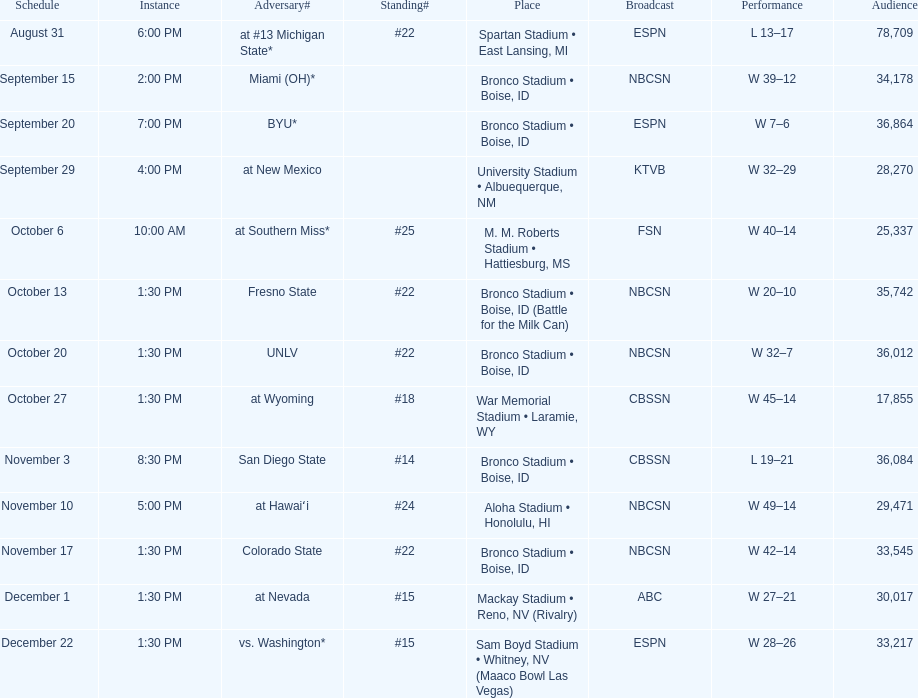What was the greatest number of back-to-back wins for the team presented in the season? 7. 